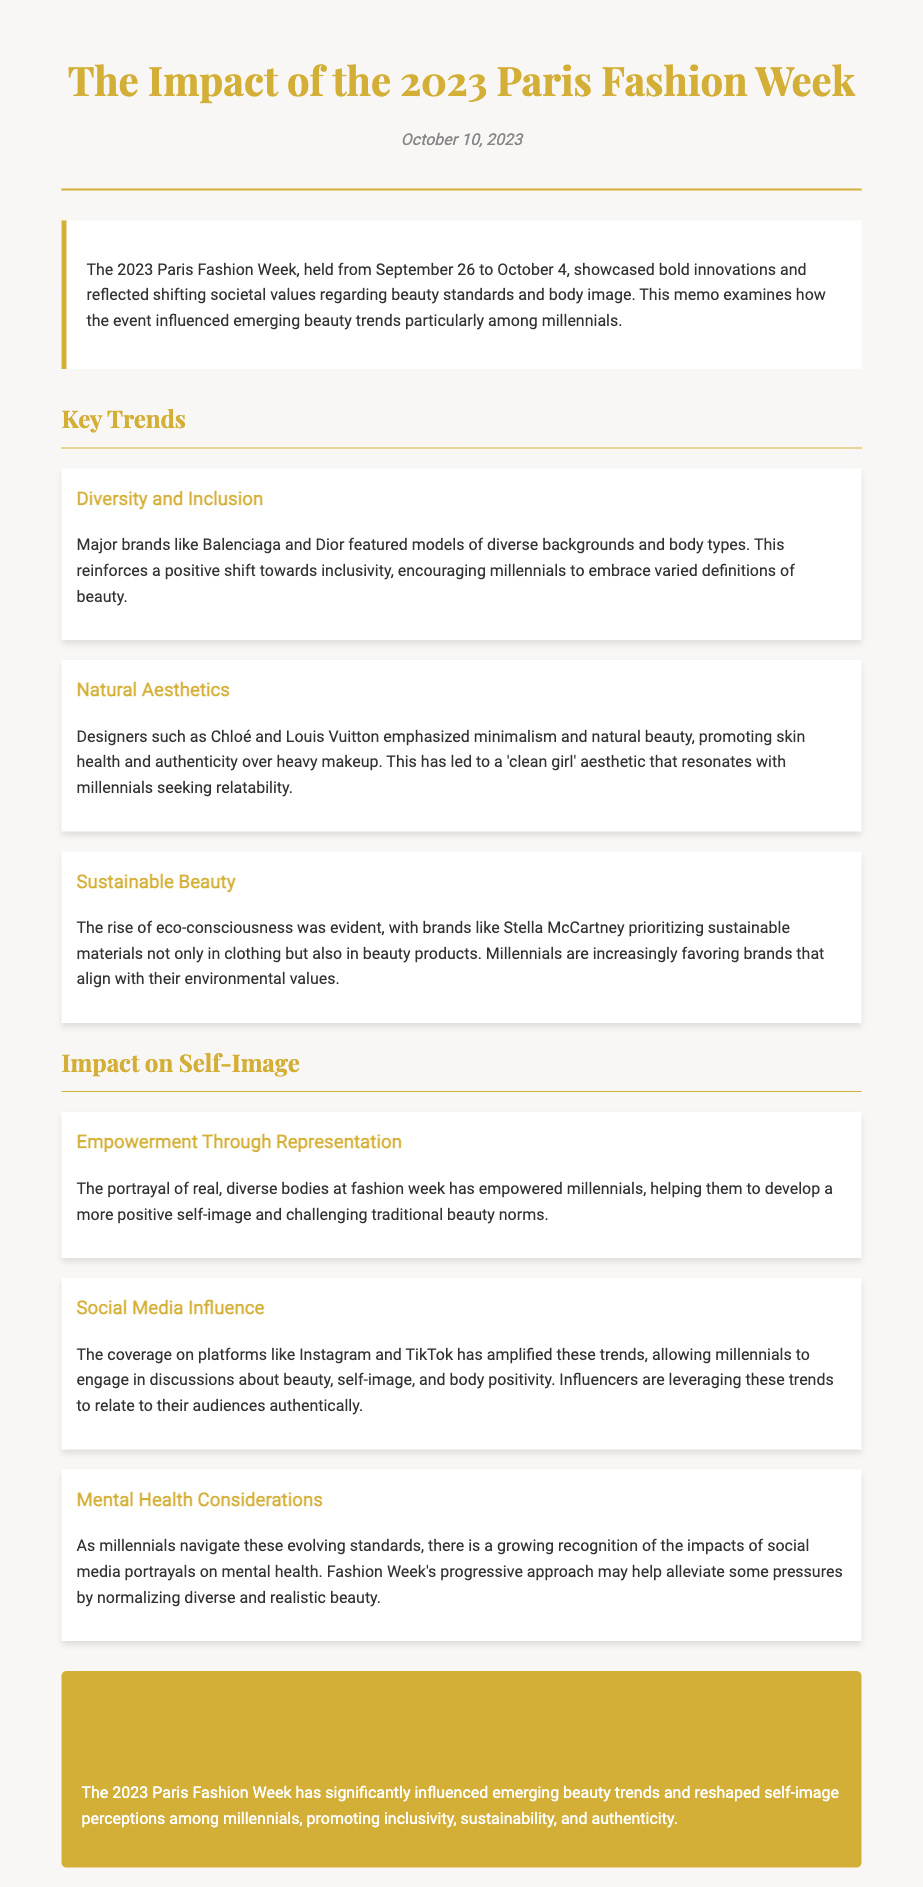What were the dates of the Paris Fashion Week 2023? The memo states that the Paris Fashion Week was held from September 26 to October 4, 2023.
Answer: September 26 to October 4, 2023 Which major brands are mentioned for embracing diversity? Balenciaga and Dior are specifically mentioned in relation to featuring models of diverse backgrounds and body types.
Answer: Balenciaga and Dior What aesthetic is promoted by designers like Chloé? The designers emphasized a minimalist and natural beauty aesthetic, which is referred to as the 'clean girl' aesthetic.
Answer: Clean girl aesthetic What key aspect did Stella McCartney prioritize during Fashion Week? The memo highlights that Stella McCartney prioritized sustainable materials in clothing and beauty products.
Answer: Sustainable materials How has social media influenced millennials' engagement with beauty trends? The memo mentions that platforms like Instagram and TikTok have allowed millennials to engage in discussions about beauty and self-image.
Answer: Discussions about beauty and self-image What is a growing recognition among millennials regarding social media? There is a growing recognition of the impacts of social media portrayals on mental health among millennials.
Answer: Impacts on mental health What positive shift is encouraged by the portrayal of diverse bodies? The portrayal of real, diverse bodies at fashion week empowers millennials and helps them develop a more positive self-image.
Answer: Positive self-image What is the overarching conclusion drawn in the memo? The conclusion summarizes that the 2023 Paris Fashion Week significantly influenced beauty trends and reshaped self-image perceptions among millennials.
Answer: Influenced beauty trends and reshaped self-image perceptions among millennials 